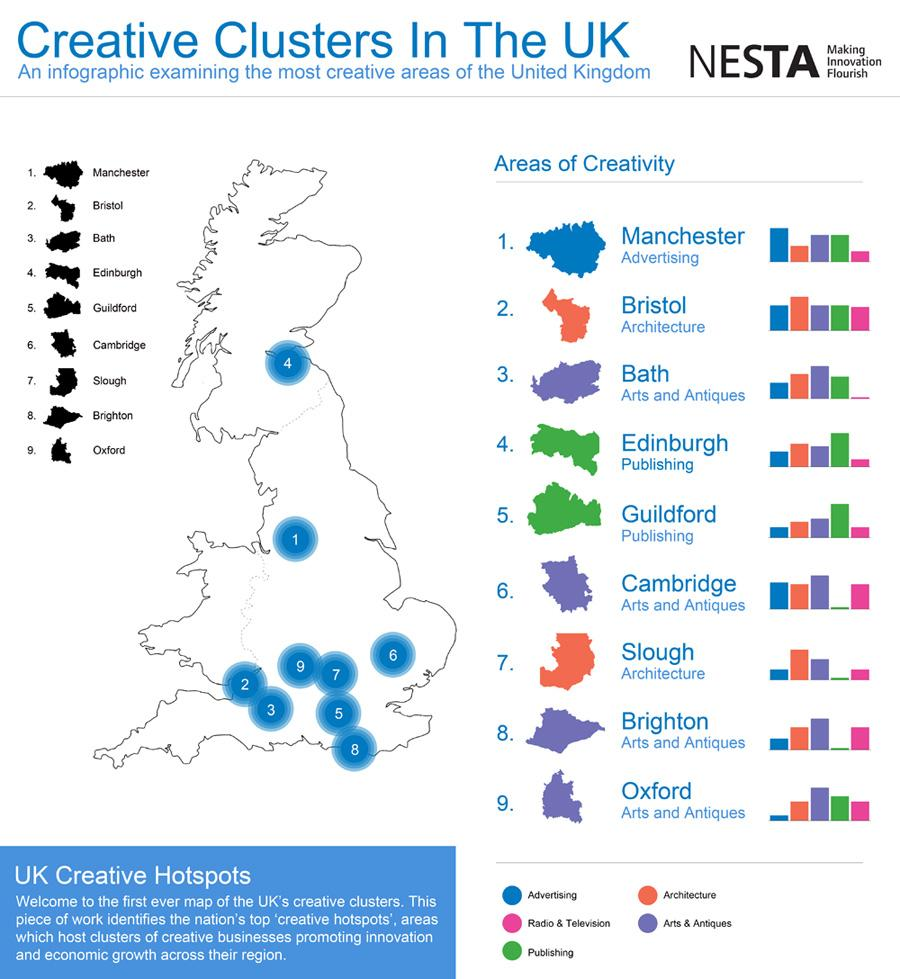Outline some significant characteristics in this image. The city of Oxford is renowned for its excellence in the field of arts and antiques. The city of Cambridge is renowned for its preeminence in the creative field of arts and antiques. During the 20th century, Bristol and Slough were the most significant cities in the United Kingdom for architecture. Manchester is the hotspot for advertising in the United Kingdom. During the 18th and 19th centuries, Edinburgh and Guildford in the United Kingdom were the primary hotspots for publishing in the country. 